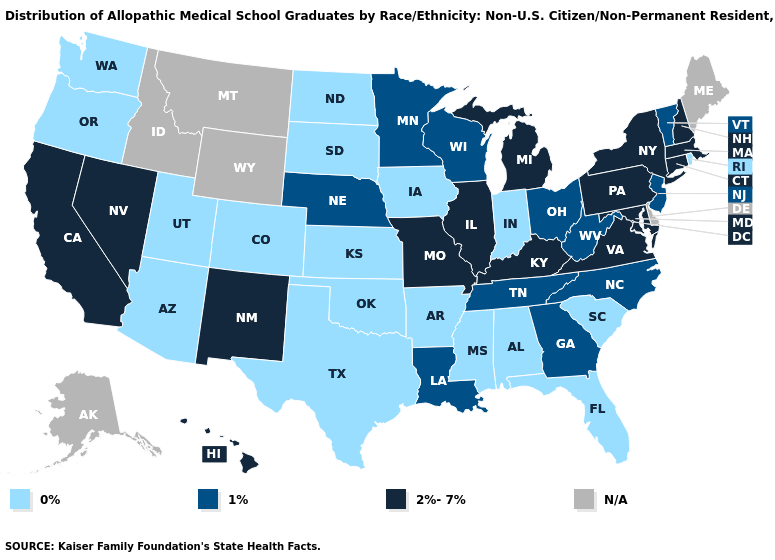Name the states that have a value in the range N/A?
Answer briefly. Alaska, Delaware, Idaho, Maine, Montana, Wyoming. What is the lowest value in states that border Vermont?
Be succinct. 2%-7%. Among the states that border Utah , does Arizona have the lowest value?
Answer briefly. Yes. Among the states that border Arkansas , does Louisiana have the lowest value?
Keep it brief. No. What is the lowest value in states that border Rhode Island?
Write a very short answer. 2%-7%. Which states have the lowest value in the West?
Quick response, please. Arizona, Colorado, Oregon, Utah, Washington. Among the states that border Pennsylvania , which have the highest value?
Write a very short answer. Maryland, New York. What is the value of Missouri?
Write a very short answer. 2%-7%. Does the map have missing data?
Concise answer only. Yes. Among the states that border Wisconsin , which have the lowest value?
Concise answer only. Iowa. Which states have the lowest value in the West?
Concise answer only. Arizona, Colorado, Oregon, Utah, Washington. Is the legend a continuous bar?
Keep it brief. No. Among the states that border Oregon , does Washington have the lowest value?
Give a very brief answer. Yes. What is the value of North Dakota?
Short answer required. 0%. 